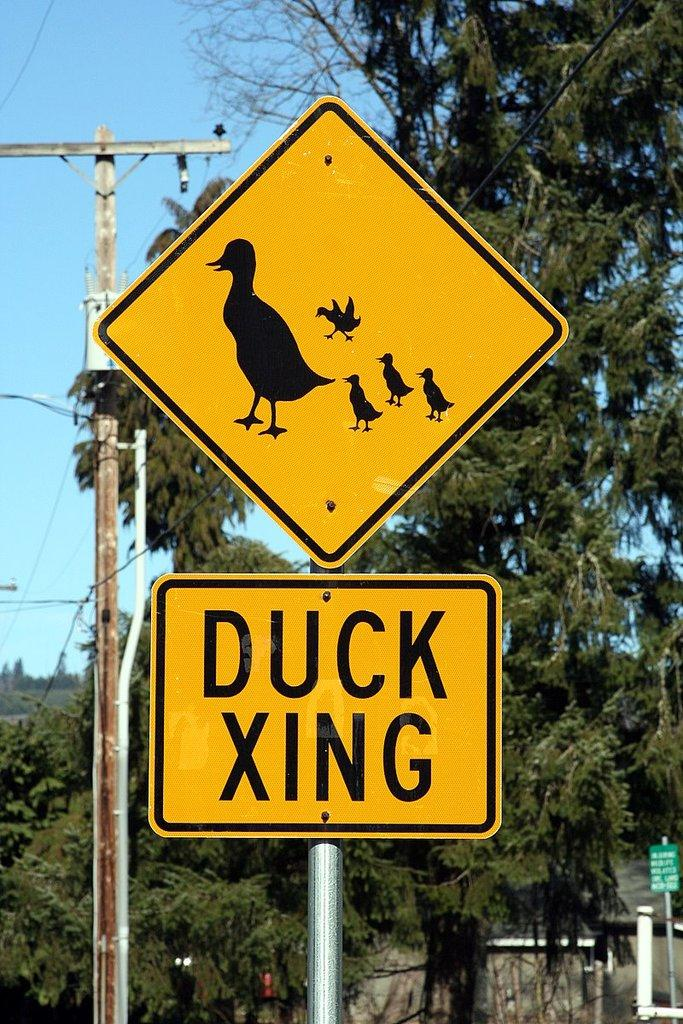<image>
Summarize the visual content of the image. a yellow sign with a duck and several ducklings says Duck Xing 